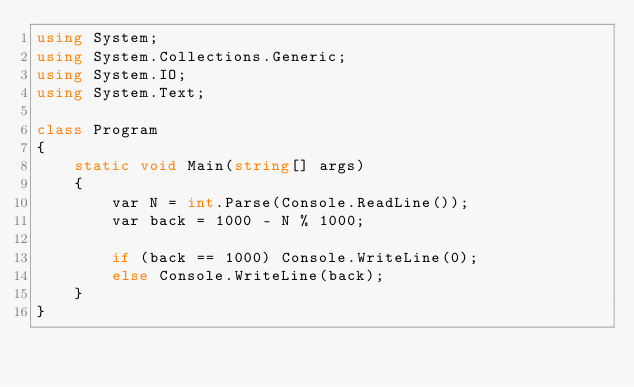<code> <loc_0><loc_0><loc_500><loc_500><_C#_>using System;
using System.Collections.Generic;
using System.IO;
using System.Text;

class Program
{
    static void Main(string[] args)
    {
        var N = int.Parse(Console.ReadLine());
        var back = 1000 - N % 1000;

        if (back == 1000) Console.WriteLine(0);
        else Console.WriteLine(back);
    }
}
</code> 